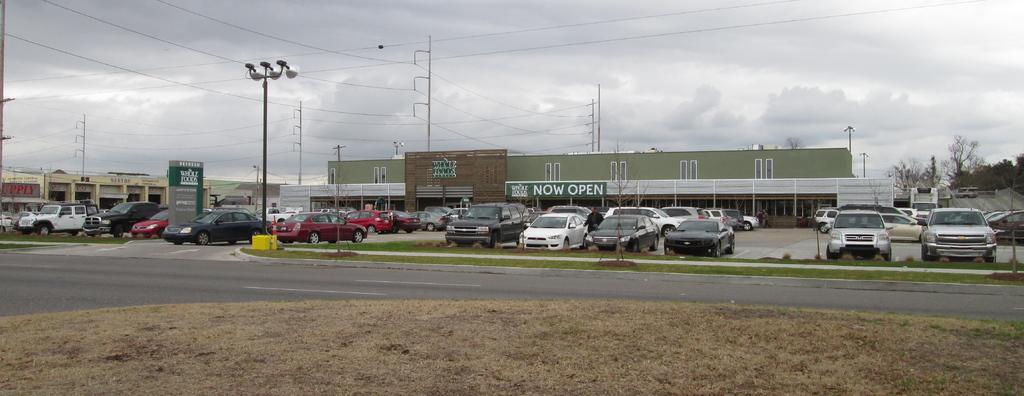<image>
Present a compact description of the photo's key features. a parking lot in front of a Whole Foods with sign NOW OPEN 